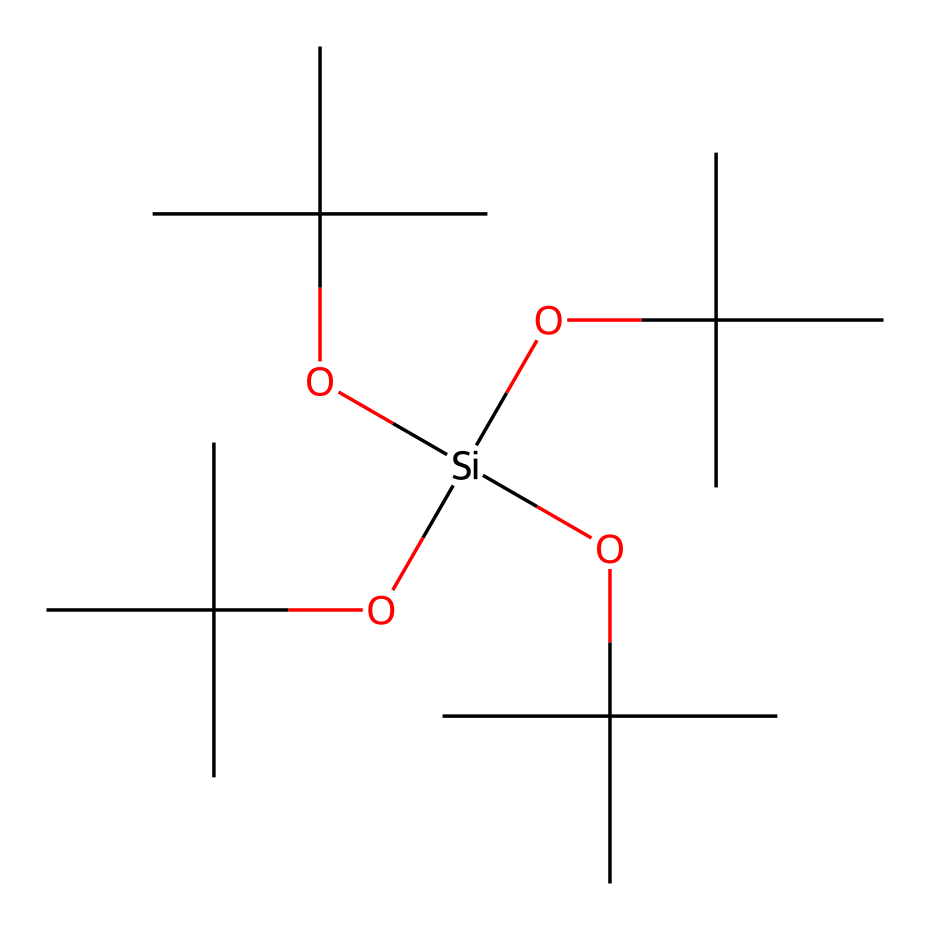What is the central atom in this silane compound? The central atom in this silane compound is silicon, which is represented by the [Si] in the SMILES notation.
Answer: silicon How many carbon atoms are present in this silane? The SMILES notation shows four carbon branches connected to the silicon, indicating there are 12 carbon atoms altogether (three from each of the four branches).
Answer: twelve What functional groups are present in this chemical structure? The chemical structure contains multiple alkoxy groups (–O–C) attached to the silicon atom, forming a silane with water-repellent properties.
Answer: alkoxy groups What is the primary use of this silane in the context of Buddhist temple roofs? This silane is primarily used for its water-repellent properties, which help protect temple roofs from weather damage and prolong their structural integrity.
Answer: water-repellent How many branched alkyl groups are attached to the silicon atom? The SMILES representation reveals that there are four branched alkyl groups (OC(C)(C)C), indicating that four are attached to the central silicon atom.
Answer: four Is this silane more likely to be hydrophilic or hydrophobic? Given its multiple alkyl groups which are hydrophobic in nature, this silane compound is primarily hydrophobic.
Answer: hydrophobic 